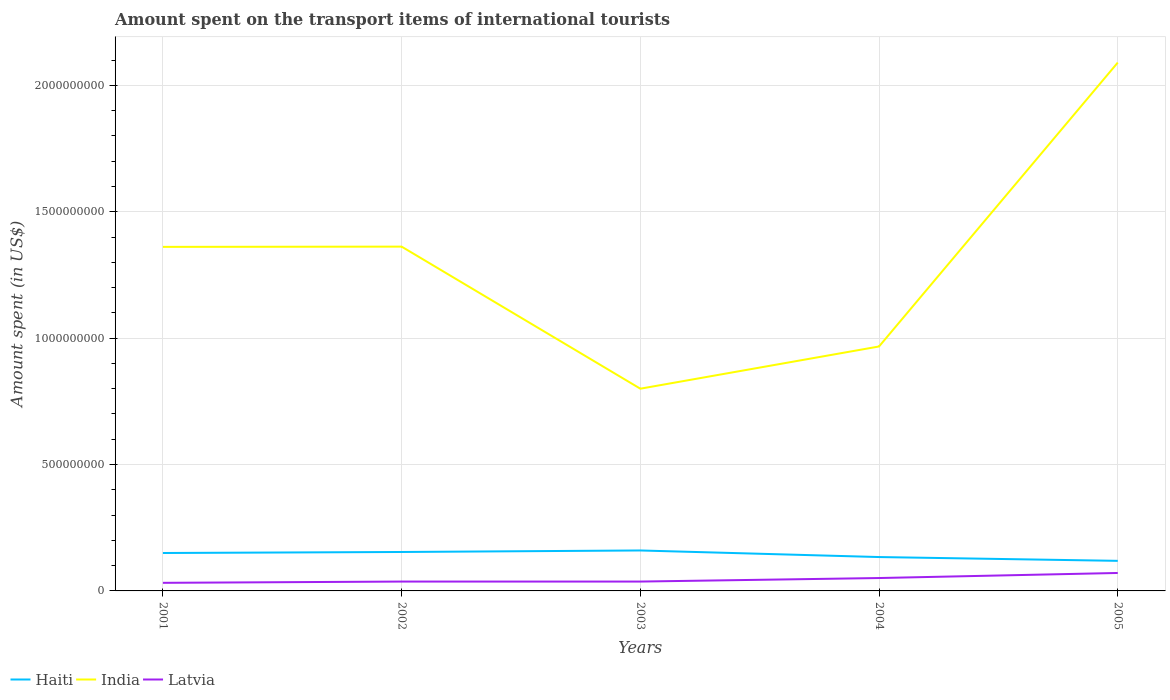Across all years, what is the maximum amount spent on the transport items of international tourists in Haiti?
Keep it short and to the point. 1.19e+08. In which year was the amount spent on the transport items of international tourists in India maximum?
Your answer should be very brief. 2003. What is the total amount spent on the transport items of international tourists in Haiti in the graph?
Provide a succinct answer. 4.10e+07. What is the difference between the highest and the second highest amount spent on the transport items of international tourists in Haiti?
Provide a short and direct response. 4.10e+07. What is the difference between the highest and the lowest amount spent on the transport items of international tourists in Latvia?
Your answer should be compact. 2. Is the amount spent on the transport items of international tourists in Latvia strictly greater than the amount spent on the transport items of international tourists in Haiti over the years?
Offer a very short reply. Yes. How many lines are there?
Offer a very short reply. 3. Does the graph contain grids?
Your answer should be very brief. Yes. Where does the legend appear in the graph?
Offer a very short reply. Bottom left. What is the title of the graph?
Make the answer very short. Amount spent on the transport items of international tourists. Does "Tanzania" appear as one of the legend labels in the graph?
Offer a terse response. No. What is the label or title of the X-axis?
Provide a short and direct response. Years. What is the label or title of the Y-axis?
Your response must be concise. Amount spent (in US$). What is the Amount spent (in US$) in Haiti in 2001?
Make the answer very short. 1.50e+08. What is the Amount spent (in US$) in India in 2001?
Give a very brief answer. 1.36e+09. What is the Amount spent (in US$) in Latvia in 2001?
Give a very brief answer. 3.20e+07. What is the Amount spent (in US$) in Haiti in 2002?
Offer a terse response. 1.54e+08. What is the Amount spent (in US$) in India in 2002?
Offer a terse response. 1.36e+09. What is the Amount spent (in US$) of Latvia in 2002?
Provide a short and direct response. 3.70e+07. What is the Amount spent (in US$) in Haiti in 2003?
Offer a terse response. 1.60e+08. What is the Amount spent (in US$) in India in 2003?
Offer a very short reply. 8.00e+08. What is the Amount spent (in US$) of Latvia in 2003?
Provide a succinct answer. 3.70e+07. What is the Amount spent (in US$) in Haiti in 2004?
Give a very brief answer. 1.34e+08. What is the Amount spent (in US$) in India in 2004?
Your answer should be compact. 9.67e+08. What is the Amount spent (in US$) of Latvia in 2004?
Your answer should be very brief. 5.10e+07. What is the Amount spent (in US$) in Haiti in 2005?
Your answer should be compact. 1.19e+08. What is the Amount spent (in US$) in India in 2005?
Your answer should be compact. 2.09e+09. What is the Amount spent (in US$) in Latvia in 2005?
Your answer should be very brief. 7.10e+07. Across all years, what is the maximum Amount spent (in US$) of Haiti?
Offer a terse response. 1.60e+08. Across all years, what is the maximum Amount spent (in US$) in India?
Keep it short and to the point. 2.09e+09. Across all years, what is the maximum Amount spent (in US$) in Latvia?
Offer a very short reply. 7.10e+07. Across all years, what is the minimum Amount spent (in US$) of Haiti?
Provide a short and direct response. 1.19e+08. Across all years, what is the minimum Amount spent (in US$) of India?
Provide a succinct answer. 8.00e+08. Across all years, what is the minimum Amount spent (in US$) in Latvia?
Give a very brief answer. 3.20e+07. What is the total Amount spent (in US$) in Haiti in the graph?
Provide a succinct answer. 7.17e+08. What is the total Amount spent (in US$) in India in the graph?
Your answer should be compact. 6.58e+09. What is the total Amount spent (in US$) in Latvia in the graph?
Ensure brevity in your answer.  2.28e+08. What is the difference between the Amount spent (in US$) of Latvia in 2001 and that in 2002?
Your response must be concise. -5.00e+06. What is the difference between the Amount spent (in US$) in Haiti in 2001 and that in 2003?
Give a very brief answer. -1.00e+07. What is the difference between the Amount spent (in US$) in India in 2001 and that in 2003?
Provide a short and direct response. 5.61e+08. What is the difference between the Amount spent (in US$) of Latvia in 2001 and that in 2003?
Your answer should be very brief. -5.00e+06. What is the difference between the Amount spent (in US$) of Haiti in 2001 and that in 2004?
Offer a terse response. 1.60e+07. What is the difference between the Amount spent (in US$) of India in 2001 and that in 2004?
Ensure brevity in your answer.  3.94e+08. What is the difference between the Amount spent (in US$) of Latvia in 2001 and that in 2004?
Give a very brief answer. -1.90e+07. What is the difference between the Amount spent (in US$) in Haiti in 2001 and that in 2005?
Provide a succinct answer. 3.10e+07. What is the difference between the Amount spent (in US$) of India in 2001 and that in 2005?
Your answer should be very brief. -7.29e+08. What is the difference between the Amount spent (in US$) in Latvia in 2001 and that in 2005?
Provide a succinct answer. -3.90e+07. What is the difference between the Amount spent (in US$) in Haiti in 2002 and that in 2003?
Your answer should be compact. -6.00e+06. What is the difference between the Amount spent (in US$) in India in 2002 and that in 2003?
Provide a short and direct response. 5.62e+08. What is the difference between the Amount spent (in US$) in India in 2002 and that in 2004?
Keep it short and to the point. 3.95e+08. What is the difference between the Amount spent (in US$) in Latvia in 2002 and that in 2004?
Your response must be concise. -1.40e+07. What is the difference between the Amount spent (in US$) of Haiti in 2002 and that in 2005?
Give a very brief answer. 3.50e+07. What is the difference between the Amount spent (in US$) of India in 2002 and that in 2005?
Your answer should be very brief. -7.28e+08. What is the difference between the Amount spent (in US$) in Latvia in 2002 and that in 2005?
Give a very brief answer. -3.40e+07. What is the difference between the Amount spent (in US$) of Haiti in 2003 and that in 2004?
Your answer should be very brief. 2.60e+07. What is the difference between the Amount spent (in US$) in India in 2003 and that in 2004?
Keep it short and to the point. -1.67e+08. What is the difference between the Amount spent (in US$) in Latvia in 2003 and that in 2004?
Provide a short and direct response. -1.40e+07. What is the difference between the Amount spent (in US$) of Haiti in 2003 and that in 2005?
Keep it short and to the point. 4.10e+07. What is the difference between the Amount spent (in US$) of India in 2003 and that in 2005?
Make the answer very short. -1.29e+09. What is the difference between the Amount spent (in US$) of Latvia in 2003 and that in 2005?
Provide a short and direct response. -3.40e+07. What is the difference between the Amount spent (in US$) of Haiti in 2004 and that in 2005?
Keep it short and to the point. 1.50e+07. What is the difference between the Amount spent (in US$) in India in 2004 and that in 2005?
Make the answer very short. -1.12e+09. What is the difference between the Amount spent (in US$) in Latvia in 2004 and that in 2005?
Make the answer very short. -2.00e+07. What is the difference between the Amount spent (in US$) of Haiti in 2001 and the Amount spent (in US$) of India in 2002?
Offer a very short reply. -1.21e+09. What is the difference between the Amount spent (in US$) of Haiti in 2001 and the Amount spent (in US$) of Latvia in 2002?
Make the answer very short. 1.13e+08. What is the difference between the Amount spent (in US$) in India in 2001 and the Amount spent (in US$) in Latvia in 2002?
Make the answer very short. 1.32e+09. What is the difference between the Amount spent (in US$) in Haiti in 2001 and the Amount spent (in US$) in India in 2003?
Provide a succinct answer. -6.50e+08. What is the difference between the Amount spent (in US$) of Haiti in 2001 and the Amount spent (in US$) of Latvia in 2003?
Provide a succinct answer. 1.13e+08. What is the difference between the Amount spent (in US$) of India in 2001 and the Amount spent (in US$) of Latvia in 2003?
Make the answer very short. 1.32e+09. What is the difference between the Amount spent (in US$) of Haiti in 2001 and the Amount spent (in US$) of India in 2004?
Your answer should be very brief. -8.17e+08. What is the difference between the Amount spent (in US$) of Haiti in 2001 and the Amount spent (in US$) of Latvia in 2004?
Your answer should be compact. 9.90e+07. What is the difference between the Amount spent (in US$) in India in 2001 and the Amount spent (in US$) in Latvia in 2004?
Offer a very short reply. 1.31e+09. What is the difference between the Amount spent (in US$) in Haiti in 2001 and the Amount spent (in US$) in India in 2005?
Provide a short and direct response. -1.94e+09. What is the difference between the Amount spent (in US$) in Haiti in 2001 and the Amount spent (in US$) in Latvia in 2005?
Make the answer very short. 7.90e+07. What is the difference between the Amount spent (in US$) of India in 2001 and the Amount spent (in US$) of Latvia in 2005?
Give a very brief answer. 1.29e+09. What is the difference between the Amount spent (in US$) of Haiti in 2002 and the Amount spent (in US$) of India in 2003?
Give a very brief answer. -6.46e+08. What is the difference between the Amount spent (in US$) of Haiti in 2002 and the Amount spent (in US$) of Latvia in 2003?
Keep it short and to the point. 1.17e+08. What is the difference between the Amount spent (in US$) of India in 2002 and the Amount spent (in US$) of Latvia in 2003?
Offer a very short reply. 1.32e+09. What is the difference between the Amount spent (in US$) of Haiti in 2002 and the Amount spent (in US$) of India in 2004?
Ensure brevity in your answer.  -8.13e+08. What is the difference between the Amount spent (in US$) of Haiti in 2002 and the Amount spent (in US$) of Latvia in 2004?
Give a very brief answer. 1.03e+08. What is the difference between the Amount spent (in US$) of India in 2002 and the Amount spent (in US$) of Latvia in 2004?
Your answer should be very brief. 1.31e+09. What is the difference between the Amount spent (in US$) in Haiti in 2002 and the Amount spent (in US$) in India in 2005?
Provide a short and direct response. -1.94e+09. What is the difference between the Amount spent (in US$) in Haiti in 2002 and the Amount spent (in US$) in Latvia in 2005?
Give a very brief answer. 8.30e+07. What is the difference between the Amount spent (in US$) in India in 2002 and the Amount spent (in US$) in Latvia in 2005?
Offer a very short reply. 1.29e+09. What is the difference between the Amount spent (in US$) of Haiti in 2003 and the Amount spent (in US$) of India in 2004?
Offer a very short reply. -8.07e+08. What is the difference between the Amount spent (in US$) of Haiti in 2003 and the Amount spent (in US$) of Latvia in 2004?
Offer a very short reply. 1.09e+08. What is the difference between the Amount spent (in US$) in India in 2003 and the Amount spent (in US$) in Latvia in 2004?
Ensure brevity in your answer.  7.49e+08. What is the difference between the Amount spent (in US$) in Haiti in 2003 and the Amount spent (in US$) in India in 2005?
Make the answer very short. -1.93e+09. What is the difference between the Amount spent (in US$) in Haiti in 2003 and the Amount spent (in US$) in Latvia in 2005?
Make the answer very short. 8.90e+07. What is the difference between the Amount spent (in US$) in India in 2003 and the Amount spent (in US$) in Latvia in 2005?
Offer a very short reply. 7.29e+08. What is the difference between the Amount spent (in US$) of Haiti in 2004 and the Amount spent (in US$) of India in 2005?
Keep it short and to the point. -1.96e+09. What is the difference between the Amount spent (in US$) in Haiti in 2004 and the Amount spent (in US$) in Latvia in 2005?
Give a very brief answer. 6.30e+07. What is the difference between the Amount spent (in US$) of India in 2004 and the Amount spent (in US$) of Latvia in 2005?
Your answer should be very brief. 8.96e+08. What is the average Amount spent (in US$) of Haiti per year?
Provide a short and direct response. 1.43e+08. What is the average Amount spent (in US$) of India per year?
Provide a succinct answer. 1.32e+09. What is the average Amount spent (in US$) in Latvia per year?
Ensure brevity in your answer.  4.56e+07. In the year 2001, what is the difference between the Amount spent (in US$) of Haiti and Amount spent (in US$) of India?
Offer a terse response. -1.21e+09. In the year 2001, what is the difference between the Amount spent (in US$) of Haiti and Amount spent (in US$) of Latvia?
Your answer should be compact. 1.18e+08. In the year 2001, what is the difference between the Amount spent (in US$) in India and Amount spent (in US$) in Latvia?
Your answer should be compact. 1.33e+09. In the year 2002, what is the difference between the Amount spent (in US$) in Haiti and Amount spent (in US$) in India?
Your response must be concise. -1.21e+09. In the year 2002, what is the difference between the Amount spent (in US$) in Haiti and Amount spent (in US$) in Latvia?
Ensure brevity in your answer.  1.17e+08. In the year 2002, what is the difference between the Amount spent (in US$) in India and Amount spent (in US$) in Latvia?
Keep it short and to the point. 1.32e+09. In the year 2003, what is the difference between the Amount spent (in US$) in Haiti and Amount spent (in US$) in India?
Ensure brevity in your answer.  -6.40e+08. In the year 2003, what is the difference between the Amount spent (in US$) of Haiti and Amount spent (in US$) of Latvia?
Your answer should be very brief. 1.23e+08. In the year 2003, what is the difference between the Amount spent (in US$) in India and Amount spent (in US$) in Latvia?
Provide a short and direct response. 7.63e+08. In the year 2004, what is the difference between the Amount spent (in US$) of Haiti and Amount spent (in US$) of India?
Your answer should be compact. -8.33e+08. In the year 2004, what is the difference between the Amount spent (in US$) in Haiti and Amount spent (in US$) in Latvia?
Make the answer very short. 8.30e+07. In the year 2004, what is the difference between the Amount spent (in US$) in India and Amount spent (in US$) in Latvia?
Your answer should be very brief. 9.16e+08. In the year 2005, what is the difference between the Amount spent (in US$) in Haiti and Amount spent (in US$) in India?
Give a very brief answer. -1.97e+09. In the year 2005, what is the difference between the Amount spent (in US$) in Haiti and Amount spent (in US$) in Latvia?
Provide a succinct answer. 4.80e+07. In the year 2005, what is the difference between the Amount spent (in US$) of India and Amount spent (in US$) of Latvia?
Provide a succinct answer. 2.02e+09. What is the ratio of the Amount spent (in US$) of Haiti in 2001 to that in 2002?
Offer a very short reply. 0.97. What is the ratio of the Amount spent (in US$) of Latvia in 2001 to that in 2002?
Your answer should be compact. 0.86. What is the ratio of the Amount spent (in US$) in Haiti in 2001 to that in 2003?
Offer a terse response. 0.94. What is the ratio of the Amount spent (in US$) in India in 2001 to that in 2003?
Offer a very short reply. 1.7. What is the ratio of the Amount spent (in US$) in Latvia in 2001 to that in 2003?
Offer a very short reply. 0.86. What is the ratio of the Amount spent (in US$) in Haiti in 2001 to that in 2004?
Offer a very short reply. 1.12. What is the ratio of the Amount spent (in US$) in India in 2001 to that in 2004?
Offer a terse response. 1.41. What is the ratio of the Amount spent (in US$) in Latvia in 2001 to that in 2004?
Give a very brief answer. 0.63. What is the ratio of the Amount spent (in US$) in Haiti in 2001 to that in 2005?
Provide a succinct answer. 1.26. What is the ratio of the Amount spent (in US$) of India in 2001 to that in 2005?
Keep it short and to the point. 0.65. What is the ratio of the Amount spent (in US$) in Latvia in 2001 to that in 2005?
Provide a short and direct response. 0.45. What is the ratio of the Amount spent (in US$) of Haiti in 2002 to that in 2003?
Offer a terse response. 0.96. What is the ratio of the Amount spent (in US$) in India in 2002 to that in 2003?
Your answer should be compact. 1.7. What is the ratio of the Amount spent (in US$) of Haiti in 2002 to that in 2004?
Your answer should be compact. 1.15. What is the ratio of the Amount spent (in US$) of India in 2002 to that in 2004?
Offer a terse response. 1.41. What is the ratio of the Amount spent (in US$) in Latvia in 2002 to that in 2004?
Give a very brief answer. 0.73. What is the ratio of the Amount spent (in US$) of Haiti in 2002 to that in 2005?
Provide a succinct answer. 1.29. What is the ratio of the Amount spent (in US$) in India in 2002 to that in 2005?
Your response must be concise. 0.65. What is the ratio of the Amount spent (in US$) in Latvia in 2002 to that in 2005?
Offer a very short reply. 0.52. What is the ratio of the Amount spent (in US$) of Haiti in 2003 to that in 2004?
Provide a short and direct response. 1.19. What is the ratio of the Amount spent (in US$) of India in 2003 to that in 2004?
Offer a terse response. 0.83. What is the ratio of the Amount spent (in US$) in Latvia in 2003 to that in 2004?
Your answer should be compact. 0.73. What is the ratio of the Amount spent (in US$) of Haiti in 2003 to that in 2005?
Make the answer very short. 1.34. What is the ratio of the Amount spent (in US$) of India in 2003 to that in 2005?
Offer a terse response. 0.38. What is the ratio of the Amount spent (in US$) of Latvia in 2003 to that in 2005?
Offer a terse response. 0.52. What is the ratio of the Amount spent (in US$) in Haiti in 2004 to that in 2005?
Provide a succinct answer. 1.13. What is the ratio of the Amount spent (in US$) in India in 2004 to that in 2005?
Ensure brevity in your answer.  0.46. What is the ratio of the Amount spent (in US$) of Latvia in 2004 to that in 2005?
Offer a very short reply. 0.72. What is the difference between the highest and the second highest Amount spent (in US$) in Haiti?
Your response must be concise. 6.00e+06. What is the difference between the highest and the second highest Amount spent (in US$) in India?
Provide a succinct answer. 7.28e+08. What is the difference between the highest and the second highest Amount spent (in US$) in Latvia?
Provide a succinct answer. 2.00e+07. What is the difference between the highest and the lowest Amount spent (in US$) of Haiti?
Make the answer very short. 4.10e+07. What is the difference between the highest and the lowest Amount spent (in US$) of India?
Your answer should be very brief. 1.29e+09. What is the difference between the highest and the lowest Amount spent (in US$) in Latvia?
Offer a terse response. 3.90e+07. 